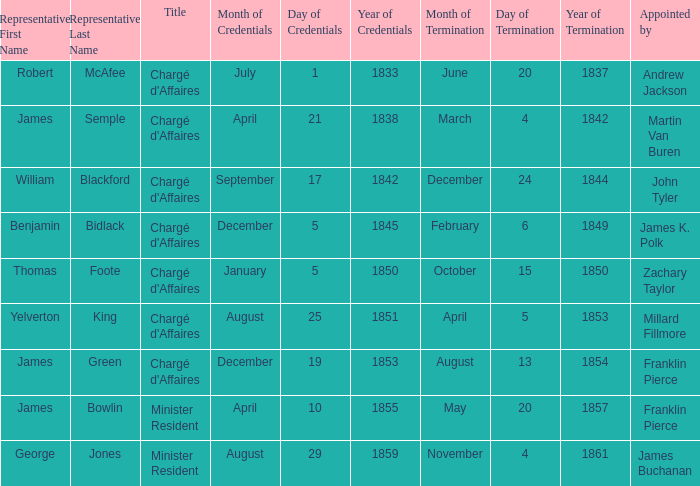What's the Termination of Mission listed that has a Presentation of Credentials for August 29, 1859? November 4, 1861. 